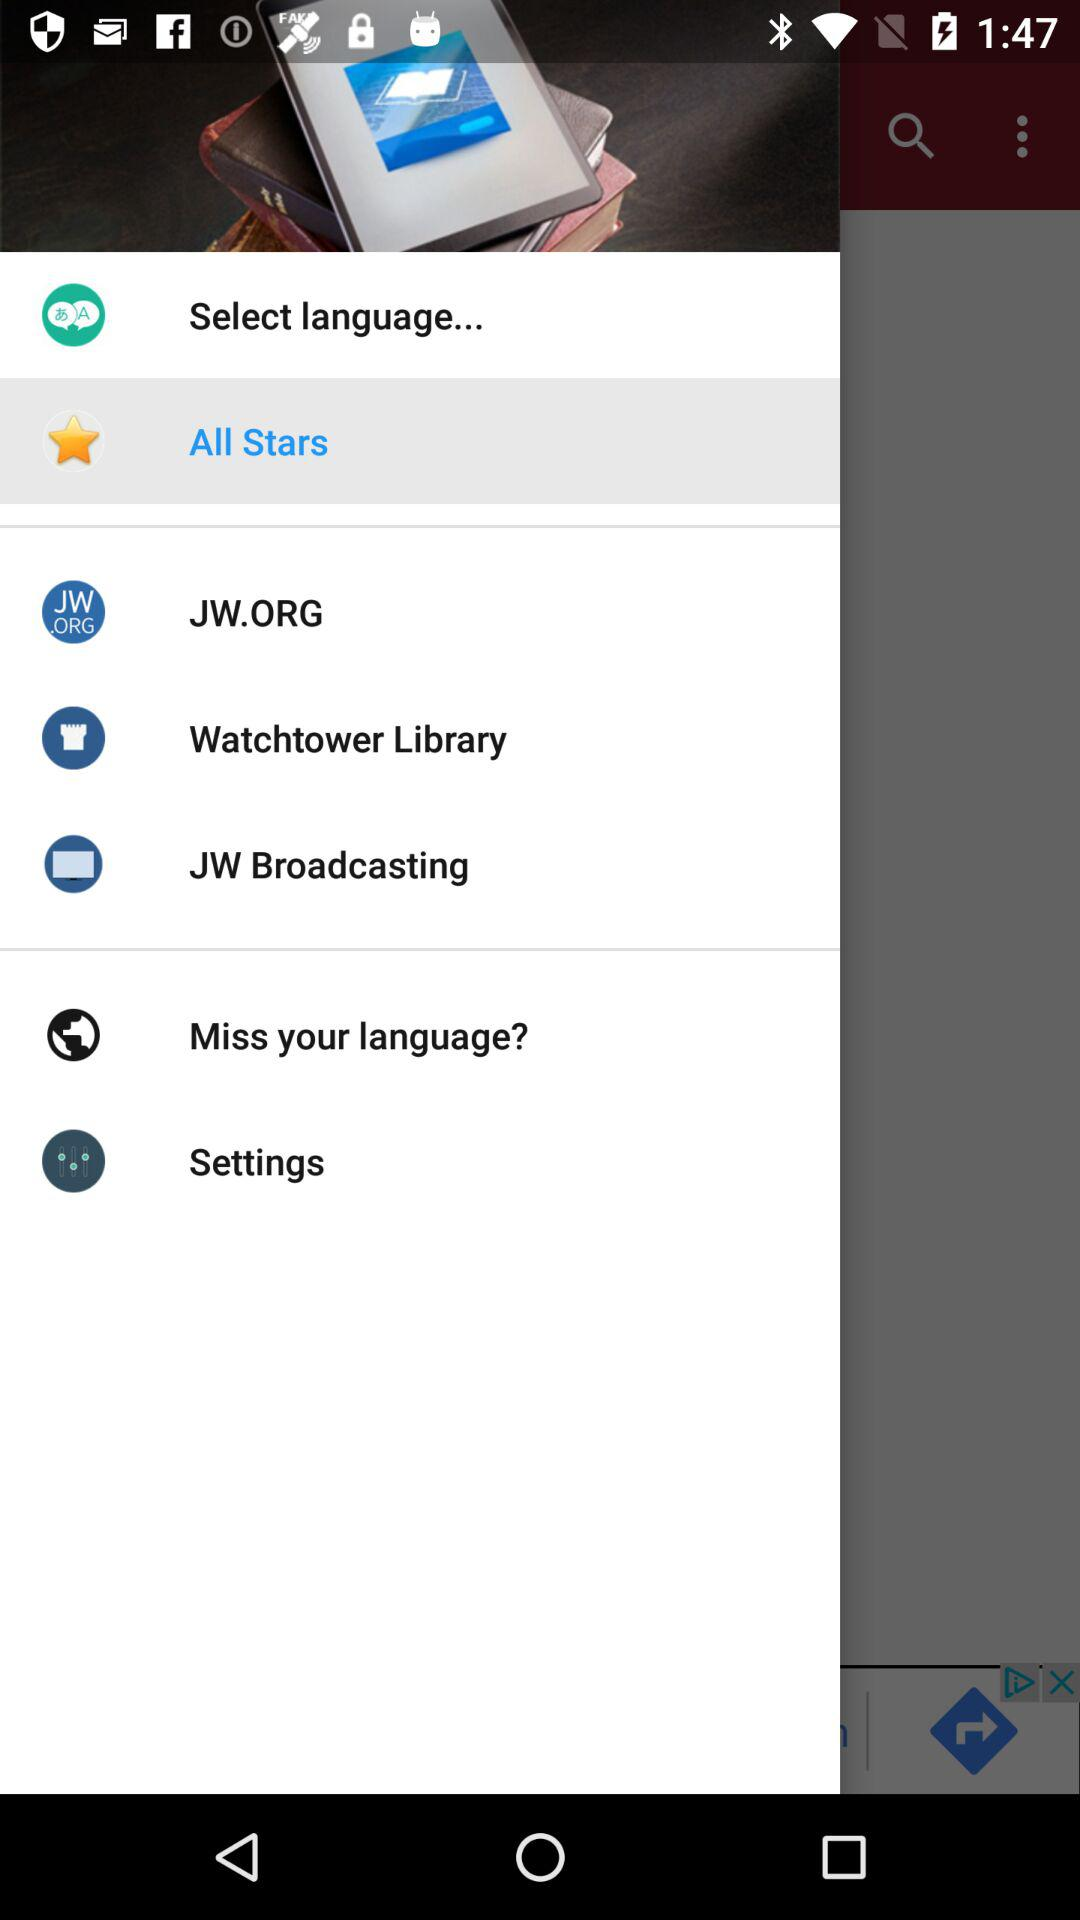Which option is selected? The selected option is All Stars. 